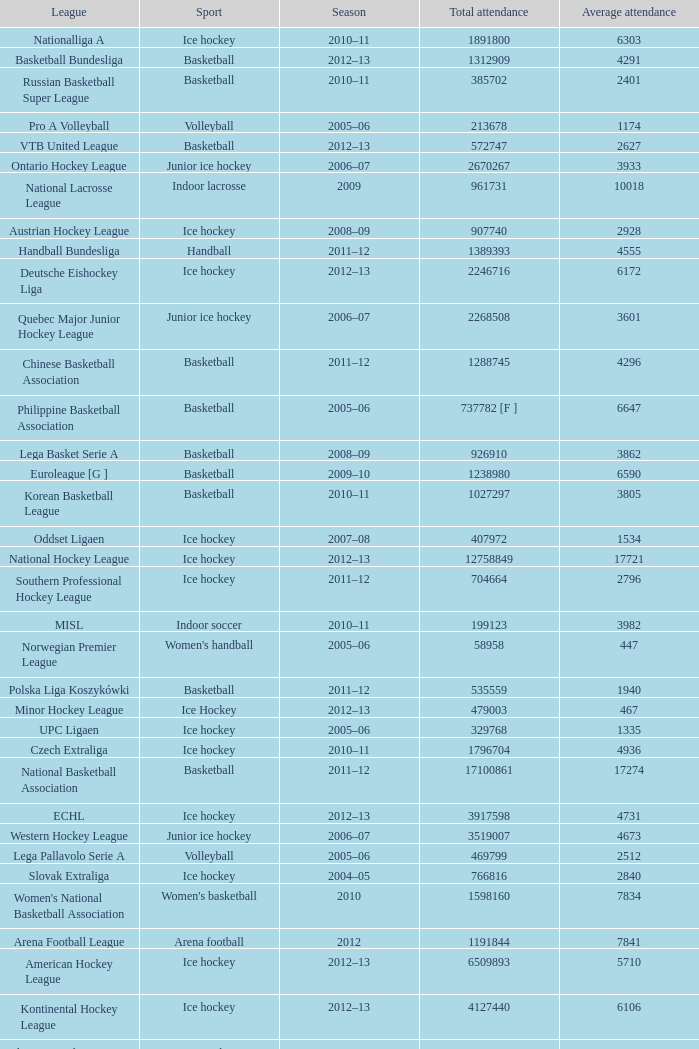What's the total attendance in rink hockey when the average attendance was smaller than 4850? 115000.0. Write the full table. {'header': ['League', 'Sport', 'Season', 'Total attendance', 'Average attendance'], 'rows': [['Nationalliga A', 'Ice hockey', '2010–11', '1891800', '6303'], ['Basketball Bundesliga', 'Basketball', '2012–13', '1312909', '4291'], ['Russian Basketball Super League', 'Basketball', '2010–11', '385702', '2401'], ['Pro A Volleyball', 'Volleyball', '2005–06', '213678', '1174'], ['VTB United League', 'Basketball', '2012–13', '572747', '2627'], ['Ontario Hockey League', 'Junior ice hockey', '2006–07', '2670267', '3933'], ['National Lacrosse League', 'Indoor lacrosse', '2009', '961731', '10018'], ['Austrian Hockey League', 'Ice hockey', '2008–09', '907740', '2928'], ['Handball Bundesliga', 'Handball', '2011–12', '1389393', '4555'], ['Deutsche Eishockey Liga', 'Ice hockey', '2012–13', '2246716', '6172'], ['Quebec Major Junior Hockey League', 'Junior ice hockey', '2006–07', '2268508', '3601'], ['Chinese Basketball Association', 'Basketball', '2011–12', '1288745', '4296'], ['Philippine Basketball Association', 'Basketball', '2005–06', '737782 [F ]', '6647'], ['Lega Basket Serie A', 'Basketball', '2008–09', '926910', '3862'], ['Euroleague [G ]', 'Basketball', '2009–10', '1238980', '6590'], ['Korean Basketball League', 'Basketball', '2010–11', '1027297', '3805'], ['Oddset Ligaen', 'Ice hockey', '2007–08', '407972', '1534'], ['National Hockey League', 'Ice hockey', '2012–13', '12758849', '17721'], ['Southern Professional Hockey League', 'Ice hockey', '2011–12', '704664', '2796'], ['MISL', 'Indoor soccer', '2010–11', '199123', '3982'], ['Norwegian Premier League', "Women's handball", '2005–06', '58958', '447'], ['Polska Liga Koszykówki', 'Basketball', '2011–12', '535559', '1940'], ['Minor Hockey League', 'Ice Hockey', '2012–13', '479003', '467'], ['UPC Ligaen', 'Ice hockey', '2005–06', '329768', '1335'], ['Czech Extraliga', 'Ice hockey', '2010–11', '1796704', '4936'], ['National Basketball Association', 'Basketball', '2011–12', '17100861', '17274'], ['ECHL', 'Ice hockey', '2012–13', '3917598', '4731'], ['Western Hockey League', 'Junior ice hockey', '2006–07', '3519007', '4673'], ['Lega Pallavolo Serie A', 'Volleyball', '2005–06', '469799', '2512'], ['Slovak Extraliga', 'Ice hockey', '2004–05', '766816', '2840'], ["Women's National Basketball Association", "Women's basketball", '2010', '1598160', '7834'], ['Arena Football League', 'Arena football', '2012', '1191844', '7841'], ['American Hockey League', 'Ice hockey', '2012–13', '6509893', '5710'], ['Kontinental Hockey League', 'Ice hockey', '2012–13', '4127440', '6106'], ['Elite Ice Hockey League', 'Ice Hockey', '2009–10', '743040', '2322'], ['Liga ACB', 'Basketball', '2008–2009', '2149416', '7189'], ['United States Hockey League', 'Junior ice hockey', '2010–11', '1054856', '2637'], ['Central Hockey League', 'Ice hockey', '2011–12', '1867801', '4042'], ['SM-liiga', 'Ice hockey', '2010–11', '2036915', '4850'], ['Major Hockey League', 'Ice Hockey', '2012–13', '1356319', '1932'], ['National Basketball League', 'Basketball', '2012–13', '636820', '5397'], ['HockeyAllsvenskan', 'Ice hockey', '2012–13', '1174766', '3227'], ['Elitserien', 'Ice hockey', '2012–13', '1883124', '5706'], ['Italian Rink Hockey League', 'Rink hockey', '2007–08', '115000', '632'], ['North American Hockey League', 'Junior ice hockey', '2010–11', '957323', '1269'], ['LNH', 'Handball', '2012–2013', '460143', '3528'], ['af2', 'Arena football', '2005', '716422', '4873']]} 